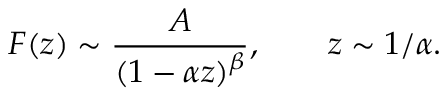<formula> <loc_0><loc_0><loc_500><loc_500>F ( z ) \sim { \frac { A } { ( 1 - \alpha z ) ^ { \beta } } } , \quad z \sim 1 / \alpha .</formula> 